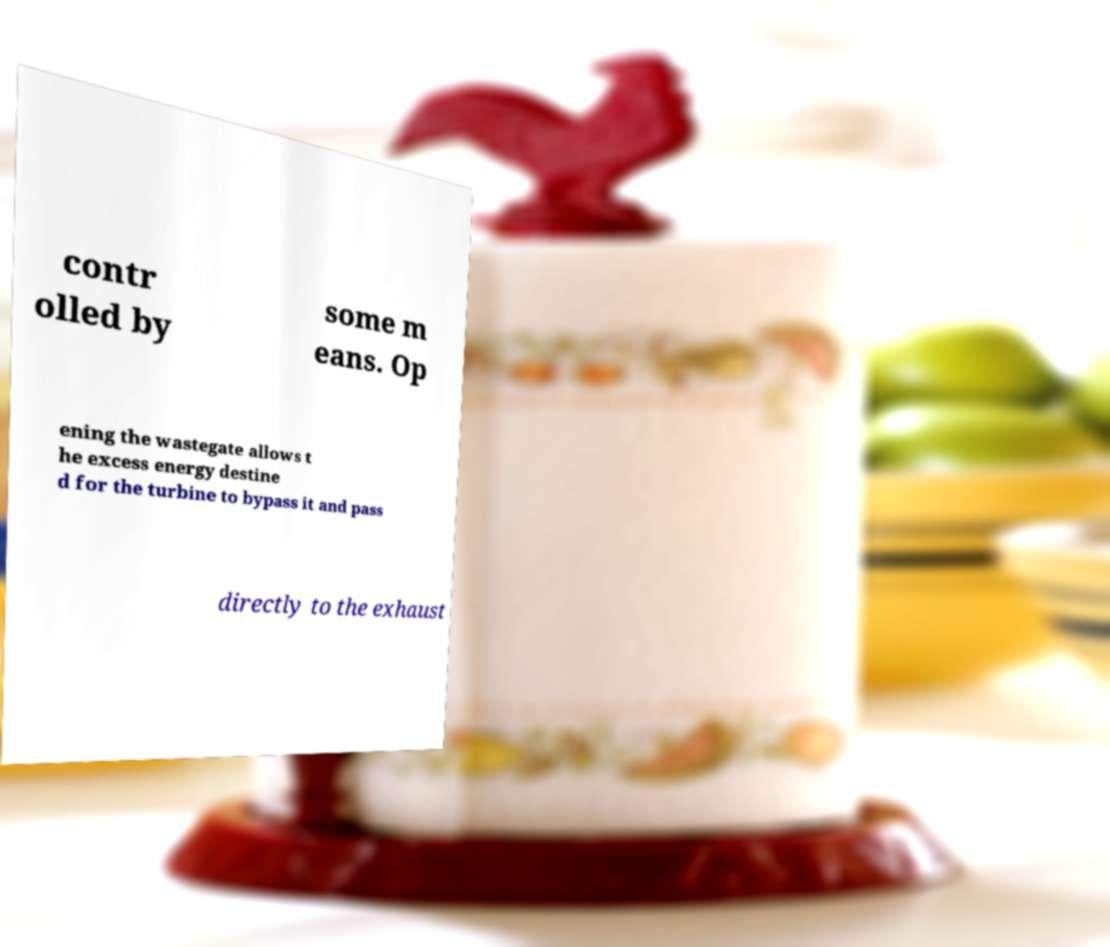What messages or text are displayed in this image? I need them in a readable, typed format. contr olled by some m eans. Op ening the wastegate allows t he excess energy destine d for the turbine to bypass it and pass directly to the exhaust 